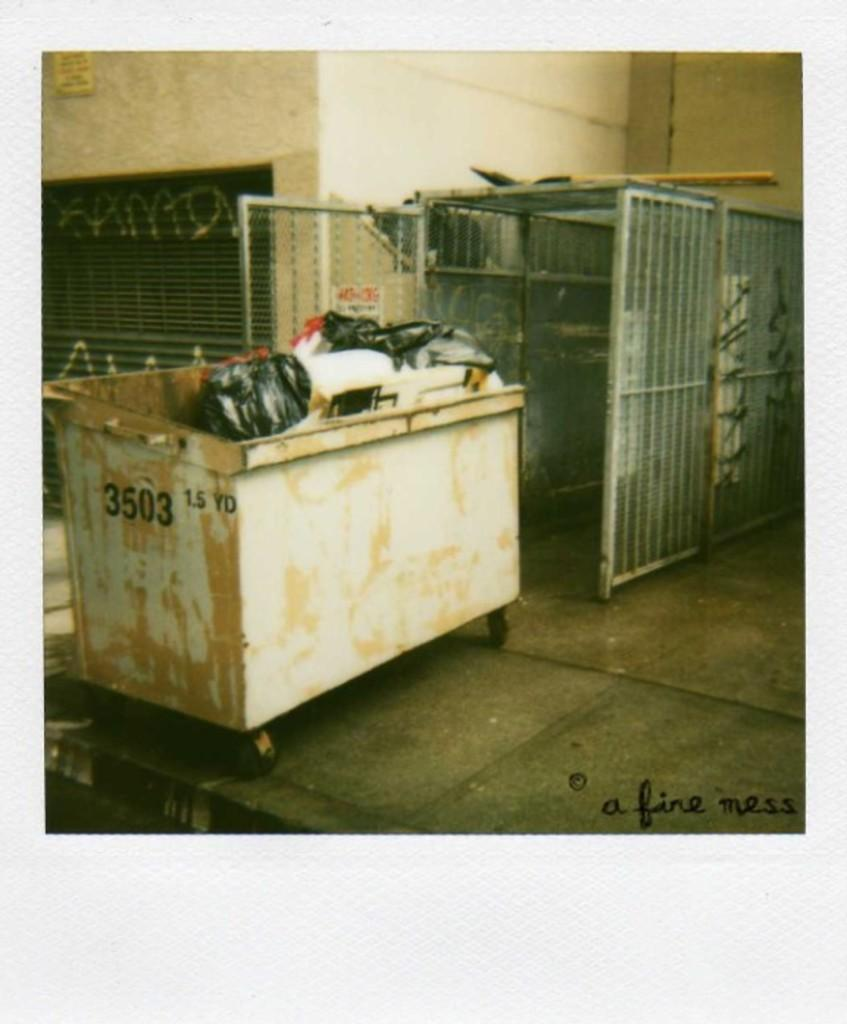What can be seen in the trolley in the image? There are many objects in the trolley. What is visible in the background of the image? There is a shed with a gate and a building in the background. What type of bat can be seen flying near the building in the image? There is no bat visible in the image; it only features a trolley with objects and a background with a shed and a building. 